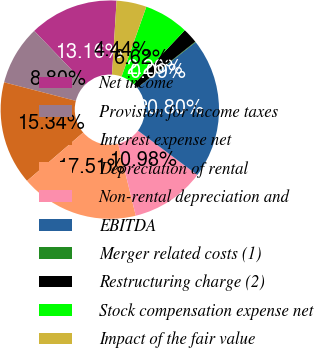<chart> <loc_0><loc_0><loc_500><loc_500><pie_chart><fcel>Net income<fcel>Provision for income taxes<fcel>Interest expense net<fcel>Depreciation of rental<fcel>Non-rental depreciation and<fcel>EBITDA<fcel>Merger related costs (1)<fcel>Restructuring charge (2)<fcel>Stock compensation expense net<fcel>Impact of the fair value<nl><fcel>13.16%<fcel>8.8%<fcel>15.34%<fcel>17.51%<fcel>10.98%<fcel>20.8%<fcel>0.09%<fcel>2.26%<fcel>6.62%<fcel>4.44%<nl></chart> 